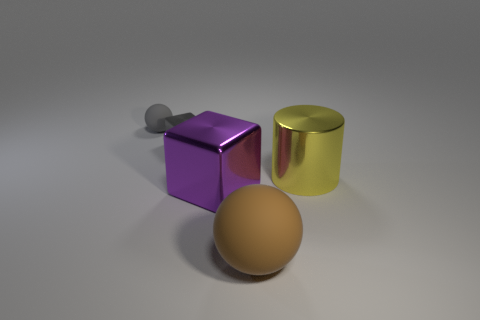What shape is the small object that is the same material as the large brown thing?
Keep it short and to the point. Sphere. The ball behind the large object on the right side of the big thing in front of the big purple metal thing is made of what material?
Offer a very short reply. Rubber. There is a purple thing; does it have the same size as the rubber sphere that is to the right of the gray metal object?
Ensure brevity in your answer.  Yes. There is a tiny object that is the same shape as the big purple object; what material is it?
Give a very brief answer. Metal. What is the size of the matte ball that is on the left side of the block that is in front of the object right of the large ball?
Offer a terse response. Small. Does the gray matte ball have the same size as the gray block?
Provide a succinct answer. Yes. There is a big object to the left of the sphere in front of the large yellow metallic thing; what is it made of?
Make the answer very short. Metal. Does the shiny thing on the left side of the large cube have the same shape as the big thing on the left side of the large rubber object?
Offer a terse response. Yes. Is the number of yellow shiny things that are to the left of the gray block the same as the number of yellow objects?
Your response must be concise. No. Are there any small things that are right of the rubber sphere that is in front of the yellow metal cylinder?
Keep it short and to the point. No. 